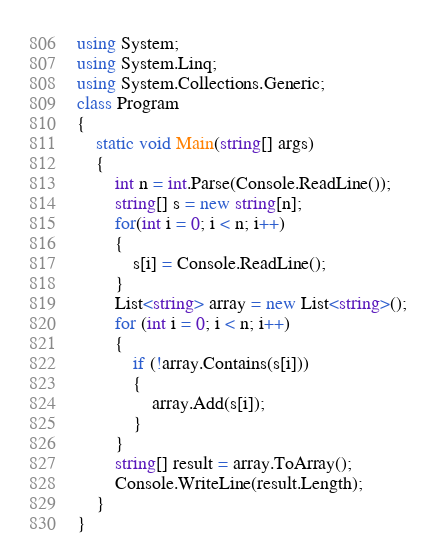<code> <loc_0><loc_0><loc_500><loc_500><_C#_>using System;
using System.Linq;
using System.Collections.Generic;
class Program
{
    static void Main(string[] args)
    {
        int n = int.Parse(Console.ReadLine());
        string[] s = new string[n];
        for(int i = 0; i < n; i++)
        {
            s[i] = Console.ReadLine();
        }
        List<string> array = new List<string>();
        for (int i = 0; i < n; i++)
        {
            if (!array.Contains(s[i]))
            {
                array.Add(s[i]);
            }
        }
        string[] result = array.ToArray();
        Console.WriteLine(result.Length);
    }
}</code> 